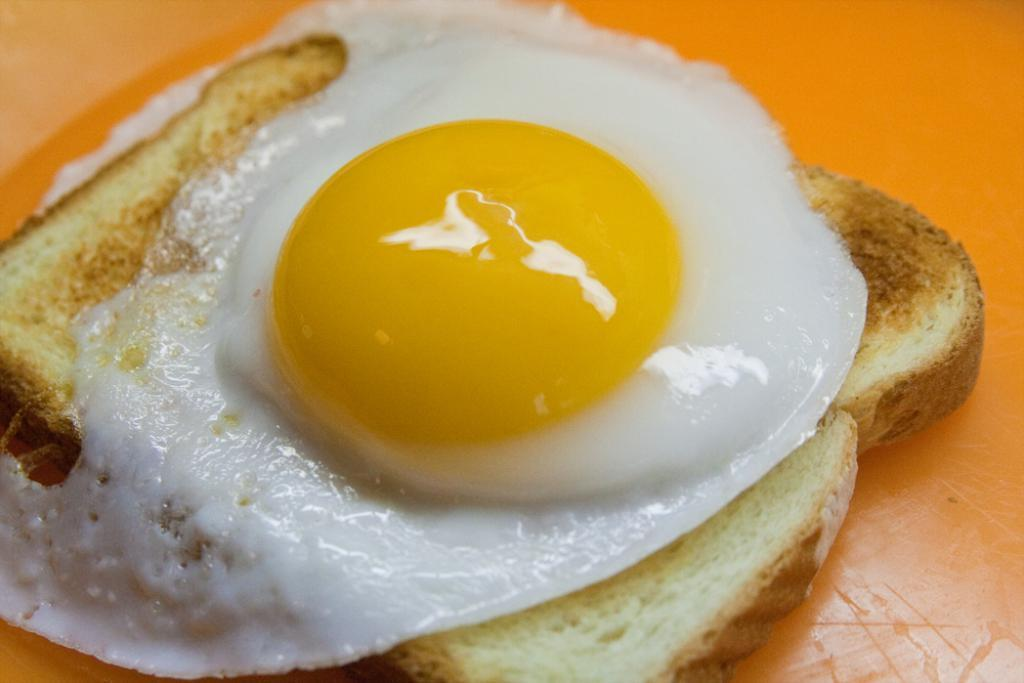What is the main food item visible in the image? There is a bread slice in the image. What is placed on top of the bread slice? There is an egg on the bread slice. How many beginner chefs are visible in the image? There is no indication of any chefs, beginner or otherwise, in the image. 